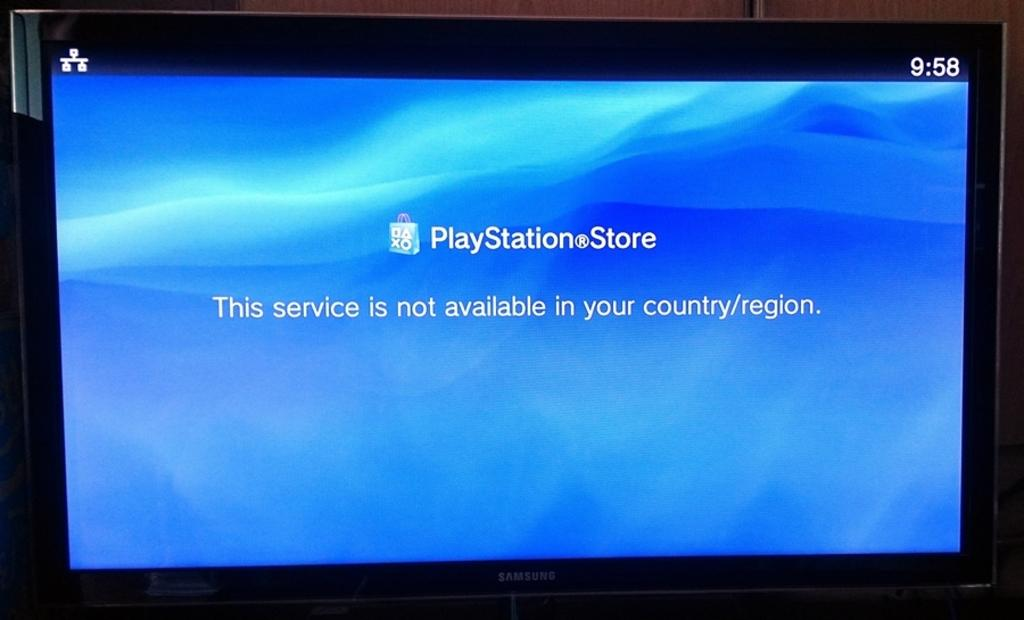Provide a one-sentence caption for the provided image. A Samsung screen displays The Playstation Store with a message that reads "this service is not available in your country/region". 